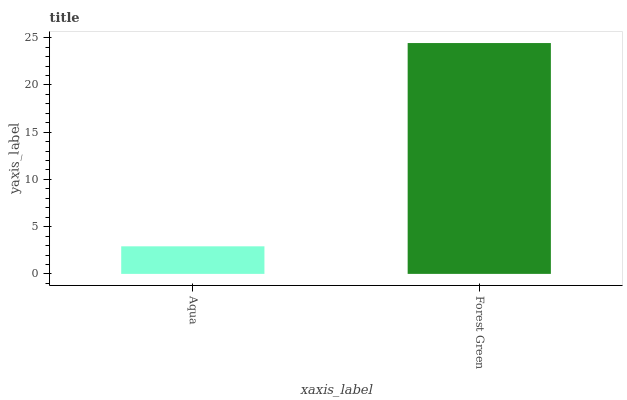Is Aqua the minimum?
Answer yes or no. Yes. Is Forest Green the maximum?
Answer yes or no. Yes. Is Forest Green the minimum?
Answer yes or no. No. Is Forest Green greater than Aqua?
Answer yes or no. Yes. Is Aqua less than Forest Green?
Answer yes or no. Yes. Is Aqua greater than Forest Green?
Answer yes or no. No. Is Forest Green less than Aqua?
Answer yes or no. No. Is Forest Green the high median?
Answer yes or no. Yes. Is Aqua the low median?
Answer yes or no. Yes. Is Aqua the high median?
Answer yes or no. No. Is Forest Green the low median?
Answer yes or no. No. 